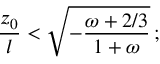<formula> <loc_0><loc_0><loc_500><loc_500>{ \frac { z _ { 0 } } { l } } < \sqrt { - { \frac { \omega + 2 / 3 } { 1 + \omega } } } \, ;</formula> 